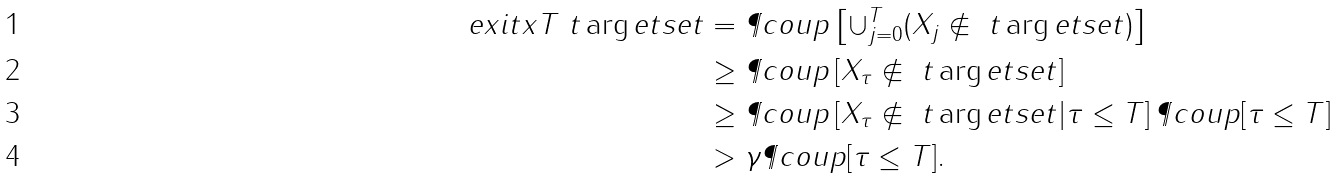<formula> <loc_0><loc_0><loc_500><loc_500>\ e x i t { x } { T } { \ t \arg e t s e t } & = \P c o u p \left [ \cup _ { j = 0 } ^ { T } ( X _ { j } \not \in \ t \arg e t s e t ) \right ] \\ & \geq \P c o u p \left [ X _ { \tau } \not \in \ t \arg e t s e t \right ] \\ & \geq \P c o u p \left [ X _ { \tau } \not \in \ t \arg e t s e t | \tau \leq T \right ] \P c o u p [ \tau \leq T ] \\ & > \gamma \P c o u p [ \tau \leq T ] . \</formula> 